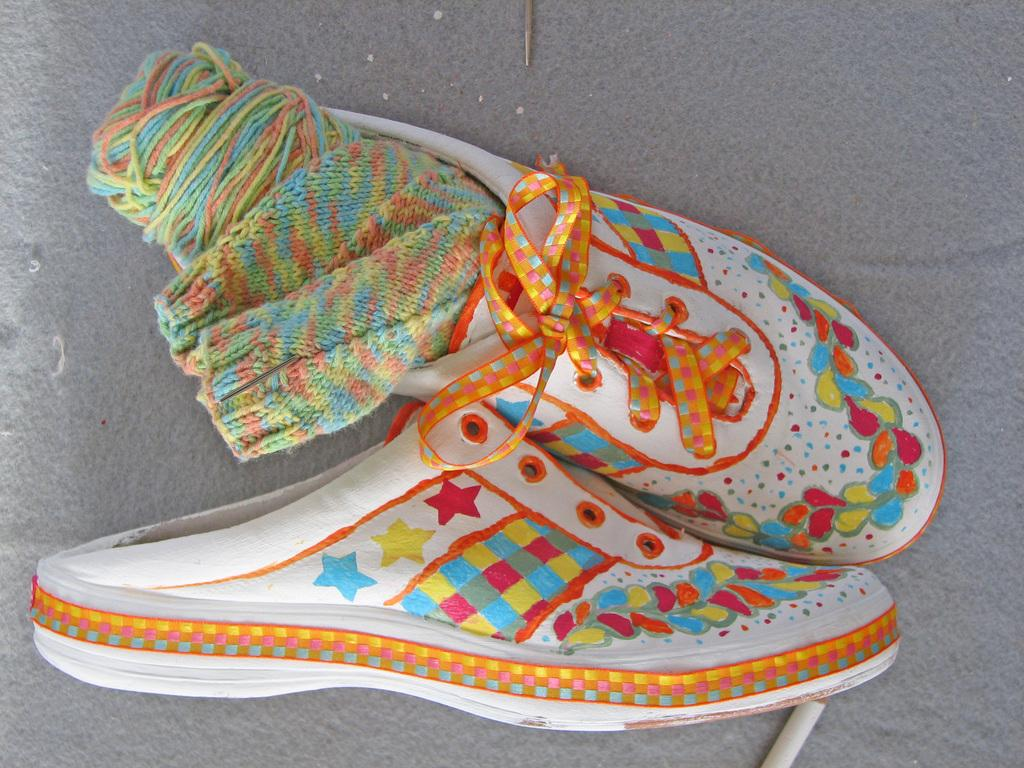What type of footwear is visible in the image? There are shoes in the image. What else is present with the shoes in the image? There are socks in the image. Where are the shoes and socks located in the image? The shoes and socks are placed on the ground. What type of jar can be seen in the image? There is no jar present in the image. How many family members are visible in the image? There are no family members present in the image. 